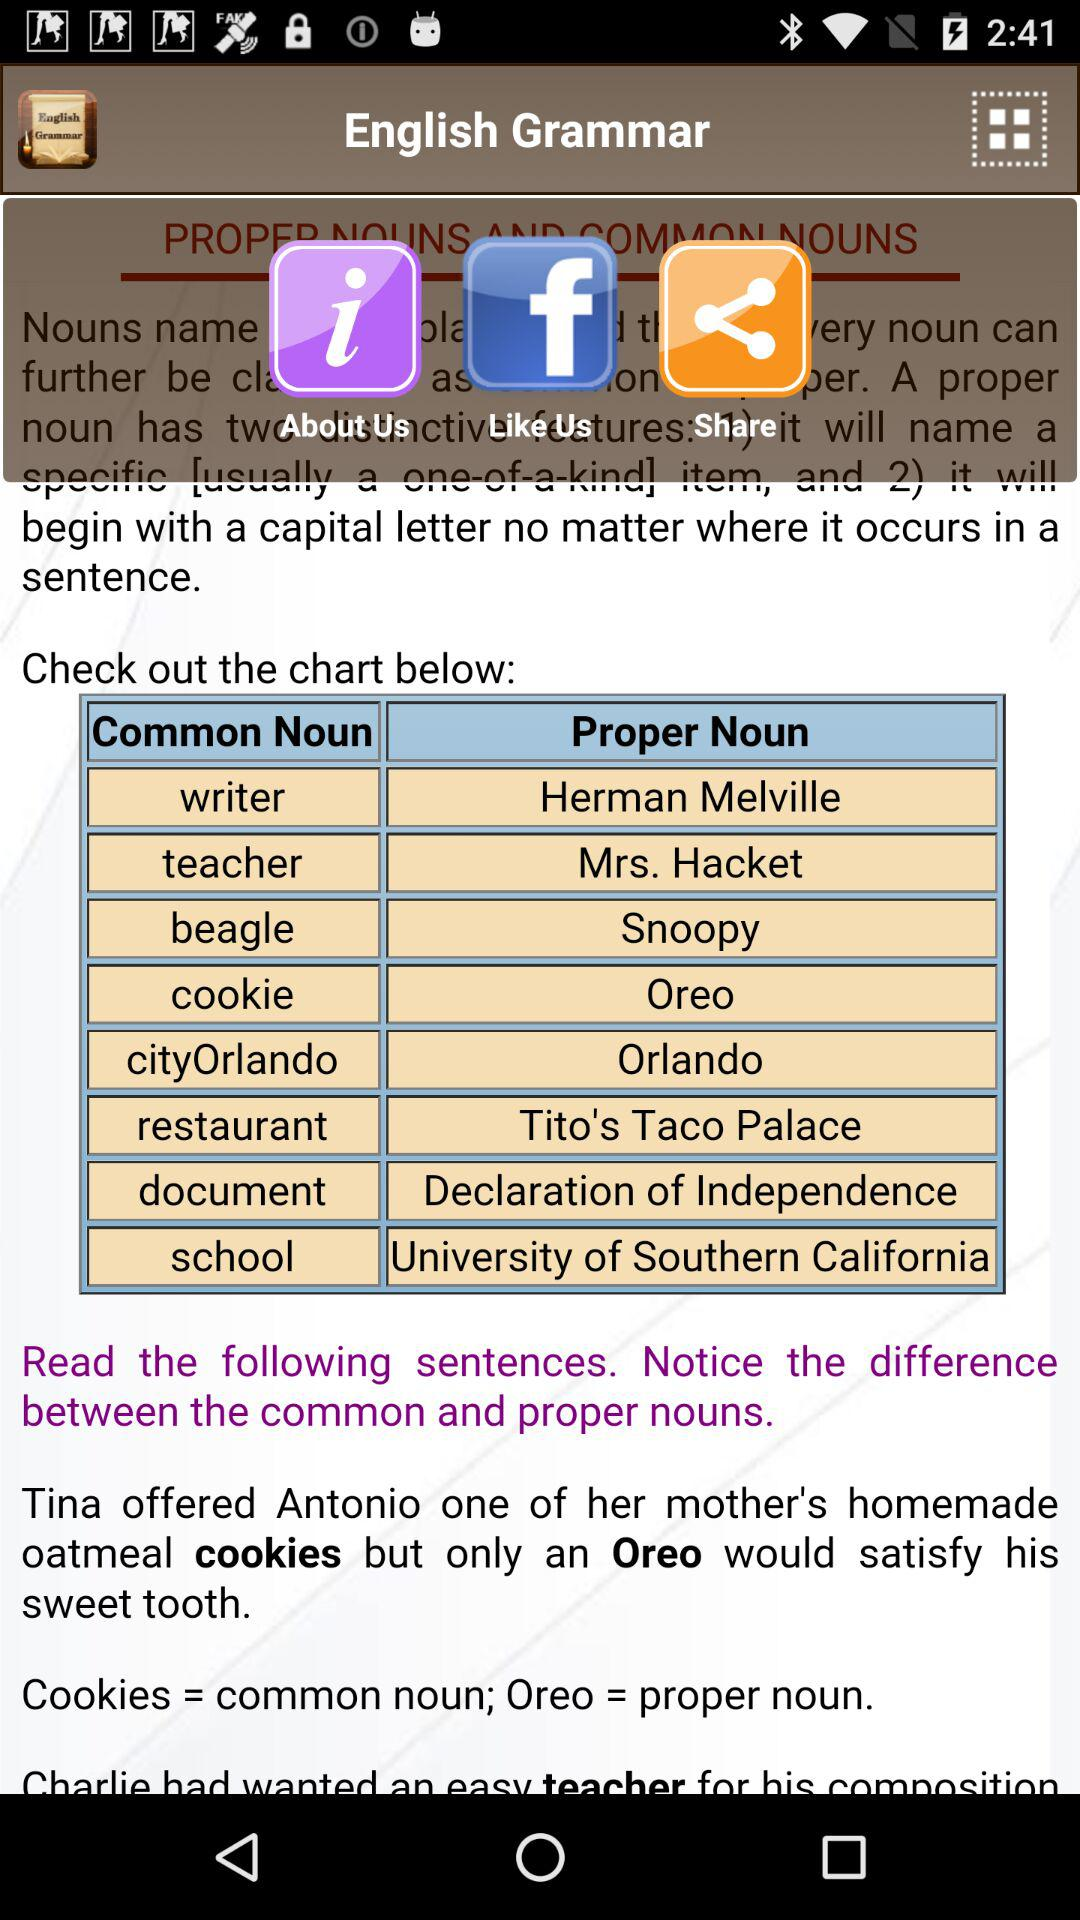What is the name of the application? The name of the application is "English Grammar". 